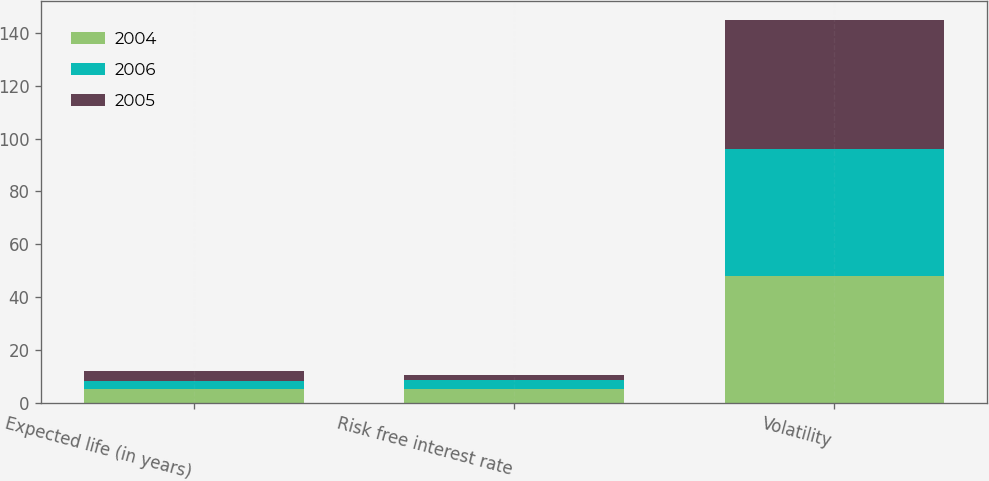Convert chart to OTSL. <chart><loc_0><loc_0><loc_500><loc_500><stacked_bar_chart><ecel><fcel>Expected life (in years)<fcel>Risk free interest rate<fcel>Volatility<nl><fcel>2004<fcel>5<fcel>5.17<fcel>48<nl><fcel>2006<fcel>3<fcel>3.25<fcel>48<nl><fcel>2005<fcel>4<fcel>2.01<fcel>49<nl></chart> 